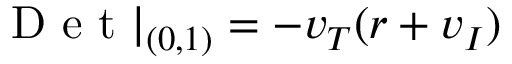<formula> <loc_0><loc_0><loc_500><loc_500>D e t | _ { ( 0 , 1 ) } = - v _ { T } ( r + v _ { I } )</formula> 